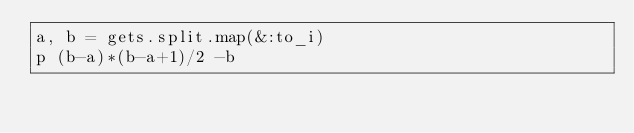<code> <loc_0><loc_0><loc_500><loc_500><_Ruby_>a, b = gets.split.map(&:to_i)
p (b-a)*(b-a+1)/2 -b
</code> 